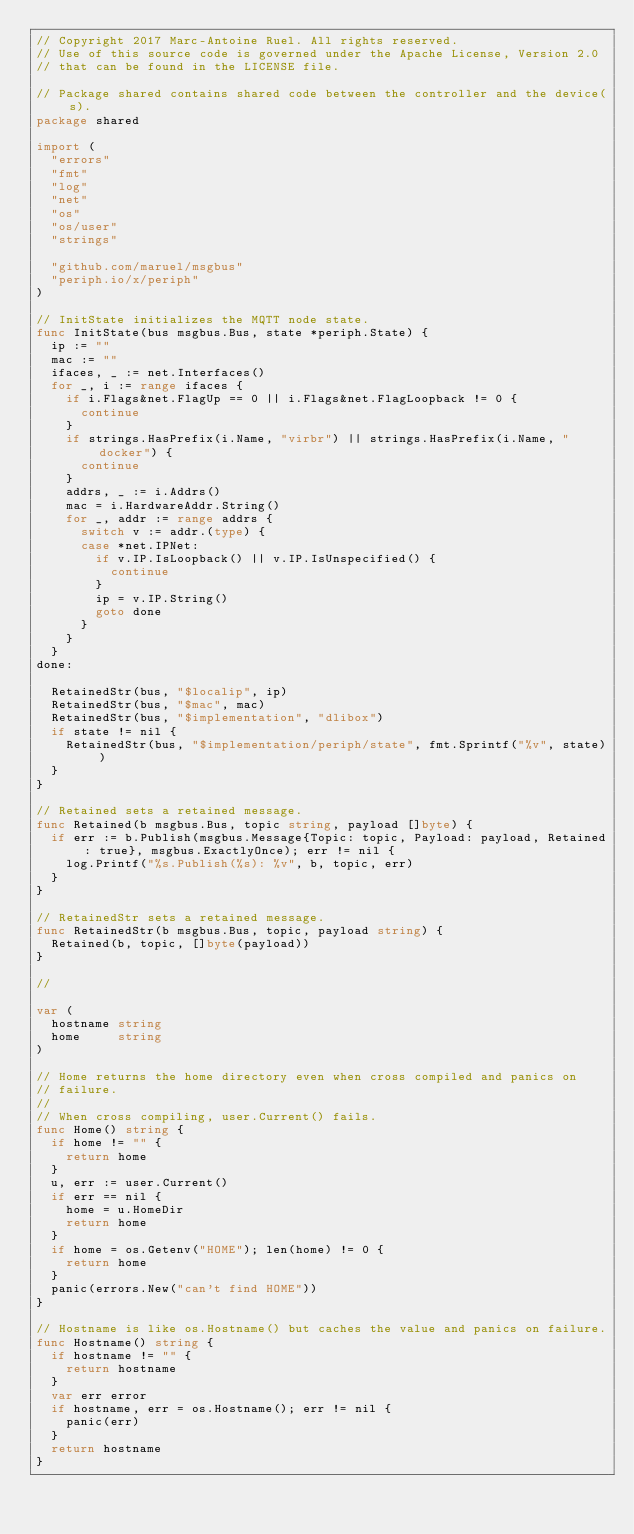<code> <loc_0><loc_0><loc_500><loc_500><_Go_>// Copyright 2017 Marc-Antoine Ruel. All rights reserved.
// Use of this source code is governed under the Apache License, Version 2.0
// that can be found in the LICENSE file.

// Package shared contains shared code between the controller and the device(s).
package shared

import (
	"errors"
	"fmt"
	"log"
	"net"
	"os"
	"os/user"
	"strings"

	"github.com/maruel/msgbus"
	"periph.io/x/periph"
)

// InitState initializes the MQTT node state.
func InitState(bus msgbus.Bus, state *periph.State) {
	ip := ""
	mac := ""
	ifaces, _ := net.Interfaces()
	for _, i := range ifaces {
		if i.Flags&net.FlagUp == 0 || i.Flags&net.FlagLoopback != 0 {
			continue
		}
		if strings.HasPrefix(i.Name, "virbr") || strings.HasPrefix(i.Name, "docker") {
			continue
		}
		addrs, _ := i.Addrs()
		mac = i.HardwareAddr.String()
		for _, addr := range addrs {
			switch v := addr.(type) {
			case *net.IPNet:
				if v.IP.IsLoopback() || v.IP.IsUnspecified() {
					continue
				}
				ip = v.IP.String()
				goto done
			}
		}
	}
done:

	RetainedStr(bus, "$localip", ip)
	RetainedStr(bus, "$mac", mac)
	RetainedStr(bus, "$implementation", "dlibox")
	if state != nil {
		RetainedStr(bus, "$implementation/periph/state", fmt.Sprintf("%v", state))
	}
}

// Retained sets a retained message.
func Retained(b msgbus.Bus, topic string, payload []byte) {
	if err := b.Publish(msgbus.Message{Topic: topic, Payload: payload, Retained: true}, msgbus.ExactlyOnce); err != nil {
		log.Printf("%s.Publish(%s): %v", b, topic, err)
	}
}

// RetainedStr sets a retained message.
func RetainedStr(b msgbus.Bus, topic, payload string) {
	Retained(b, topic, []byte(payload))
}

//

var (
	hostname string
	home     string
)

// Home returns the home directory even when cross compiled and panics on
// failure.
//
// When cross compiling, user.Current() fails.
func Home() string {
	if home != "" {
		return home
	}
	u, err := user.Current()
	if err == nil {
		home = u.HomeDir
		return home
	}
	if home = os.Getenv("HOME"); len(home) != 0 {
		return home
	}
	panic(errors.New("can't find HOME"))
}

// Hostname is like os.Hostname() but caches the value and panics on failure.
func Hostname() string {
	if hostname != "" {
		return hostname
	}
	var err error
	if hostname, err = os.Hostname(); err != nil {
		panic(err)
	}
	return hostname
}
</code> 